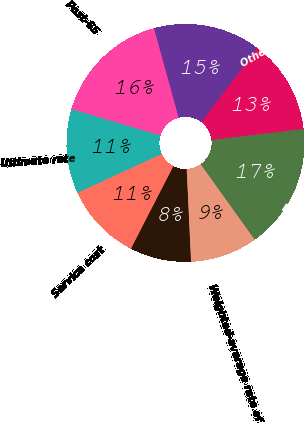Convert chart to OTSL. <chart><loc_0><loc_0><loc_500><loc_500><pie_chart><fcel>Service cost<fcel>Interest cost<fcel>Weighted-average rate of<fcel>Pension assets<fcel>Other postretirement taxable<fcel>Pre-65<fcel>Post-65<fcel>Ultimate rate<nl><fcel>10.58%<fcel>8.31%<fcel>9.15%<fcel>16.99%<fcel>12.81%<fcel>14.59%<fcel>16.15%<fcel>11.43%<nl></chart> 